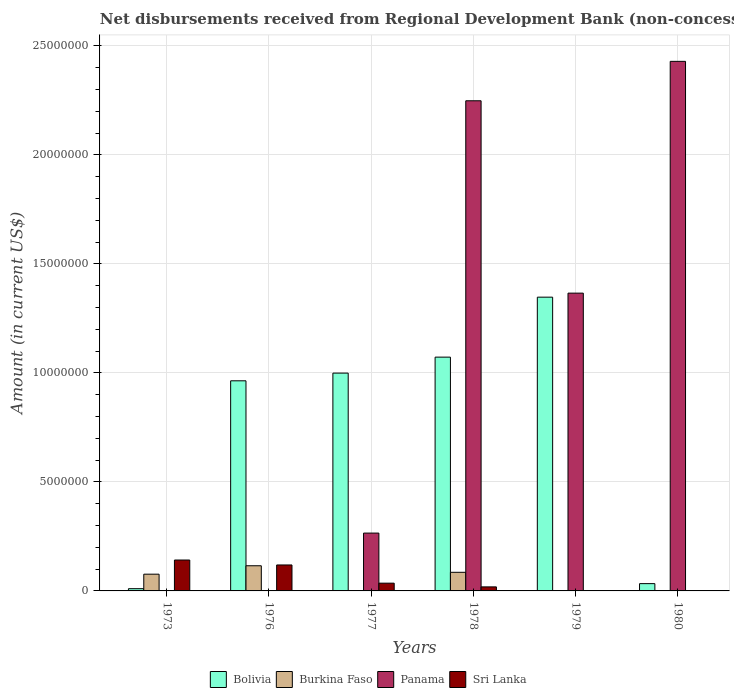Are the number of bars per tick equal to the number of legend labels?
Make the answer very short. No. Are the number of bars on each tick of the X-axis equal?
Your response must be concise. No. How many bars are there on the 5th tick from the left?
Your answer should be very brief. 2. What is the label of the 6th group of bars from the left?
Make the answer very short. 1980. In how many cases, is the number of bars for a given year not equal to the number of legend labels?
Your response must be concise. 5. What is the amount of disbursements received from Regional Development Bank in Panama in 1976?
Your answer should be very brief. 0. Across all years, what is the maximum amount of disbursements received from Regional Development Bank in Panama?
Make the answer very short. 2.43e+07. Across all years, what is the minimum amount of disbursements received from Regional Development Bank in Bolivia?
Your answer should be compact. 1.03e+05. In which year was the amount of disbursements received from Regional Development Bank in Sri Lanka maximum?
Offer a terse response. 1973. What is the total amount of disbursements received from Regional Development Bank in Sri Lanka in the graph?
Provide a short and direct response. 3.15e+06. What is the difference between the amount of disbursements received from Regional Development Bank in Bolivia in 1973 and that in 1978?
Provide a short and direct response. -1.06e+07. What is the average amount of disbursements received from Regional Development Bank in Panama per year?
Keep it short and to the point. 1.05e+07. In the year 1978, what is the difference between the amount of disbursements received from Regional Development Bank in Burkina Faso and amount of disbursements received from Regional Development Bank in Sri Lanka?
Offer a terse response. 6.69e+05. In how many years, is the amount of disbursements received from Regional Development Bank in Panama greater than 5000000 US$?
Make the answer very short. 3. What is the ratio of the amount of disbursements received from Regional Development Bank in Panama in 1978 to that in 1980?
Keep it short and to the point. 0.93. Is the amount of disbursements received from Regional Development Bank in Bolivia in 1978 less than that in 1979?
Provide a short and direct response. Yes. Is the difference between the amount of disbursements received from Regional Development Bank in Burkina Faso in 1976 and 1978 greater than the difference between the amount of disbursements received from Regional Development Bank in Sri Lanka in 1976 and 1978?
Ensure brevity in your answer.  No. What is the difference between the highest and the second highest amount of disbursements received from Regional Development Bank in Bolivia?
Give a very brief answer. 2.75e+06. What is the difference between the highest and the lowest amount of disbursements received from Regional Development Bank in Bolivia?
Offer a very short reply. 1.34e+07. In how many years, is the amount of disbursements received from Regional Development Bank in Panama greater than the average amount of disbursements received from Regional Development Bank in Panama taken over all years?
Your response must be concise. 3. Is the sum of the amount of disbursements received from Regional Development Bank in Burkina Faso in 1976 and 1978 greater than the maximum amount of disbursements received from Regional Development Bank in Bolivia across all years?
Provide a succinct answer. No. Is it the case that in every year, the sum of the amount of disbursements received from Regional Development Bank in Bolivia and amount of disbursements received from Regional Development Bank in Sri Lanka is greater than the sum of amount of disbursements received from Regional Development Bank in Panama and amount of disbursements received from Regional Development Bank in Burkina Faso?
Ensure brevity in your answer.  No. Is it the case that in every year, the sum of the amount of disbursements received from Regional Development Bank in Panama and amount of disbursements received from Regional Development Bank in Bolivia is greater than the amount of disbursements received from Regional Development Bank in Burkina Faso?
Offer a very short reply. No. How many bars are there?
Your answer should be compact. 17. Are all the bars in the graph horizontal?
Provide a short and direct response. No. Does the graph contain any zero values?
Give a very brief answer. Yes. Does the graph contain grids?
Keep it short and to the point. Yes. How many legend labels are there?
Make the answer very short. 4. How are the legend labels stacked?
Give a very brief answer. Horizontal. What is the title of the graph?
Provide a succinct answer. Net disbursements received from Regional Development Bank (non-concessional). Does "Low & middle income" appear as one of the legend labels in the graph?
Offer a very short reply. No. What is the label or title of the Y-axis?
Offer a very short reply. Amount (in current US$). What is the Amount (in current US$) of Bolivia in 1973?
Offer a terse response. 1.03e+05. What is the Amount (in current US$) in Burkina Faso in 1973?
Your answer should be very brief. 7.68e+05. What is the Amount (in current US$) in Sri Lanka in 1973?
Your answer should be very brief. 1.42e+06. What is the Amount (in current US$) of Bolivia in 1976?
Your answer should be compact. 9.64e+06. What is the Amount (in current US$) of Burkina Faso in 1976?
Offer a very short reply. 1.15e+06. What is the Amount (in current US$) in Panama in 1976?
Make the answer very short. 0. What is the Amount (in current US$) of Sri Lanka in 1976?
Provide a succinct answer. 1.19e+06. What is the Amount (in current US$) in Bolivia in 1977?
Your answer should be very brief. 9.99e+06. What is the Amount (in current US$) of Panama in 1977?
Give a very brief answer. 2.65e+06. What is the Amount (in current US$) in Sri Lanka in 1977?
Keep it short and to the point. 3.56e+05. What is the Amount (in current US$) in Bolivia in 1978?
Offer a terse response. 1.07e+07. What is the Amount (in current US$) of Burkina Faso in 1978?
Your answer should be very brief. 8.54e+05. What is the Amount (in current US$) of Panama in 1978?
Make the answer very short. 2.25e+07. What is the Amount (in current US$) of Sri Lanka in 1978?
Give a very brief answer. 1.85e+05. What is the Amount (in current US$) in Bolivia in 1979?
Give a very brief answer. 1.35e+07. What is the Amount (in current US$) of Panama in 1979?
Keep it short and to the point. 1.37e+07. What is the Amount (in current US$) in Sri Lanka in 1979?
Give a very brief answer. 0. What is the Amount (in current US$) of Bolivia in 1980?
Your response must be concise. 3.34e+05. What is the Amount (in current US$) of Panama in 1980?
Your response must be concise. 2.43e+07. Across all years, what is the maximum Amount (in current US$) in Bolivia?
Your answer should be very brief. 1.35e+07. Across all years, what is the maximum Amount (in current US$) of Burkina Faso?
Provide a succinct answer. 1.15e+06. Across all years, what is the maximum Amount (in current US$) of Panama?
Offer a terse response. 2.43e+07. Across all years, what is the maximum Amount (in current US$) in Sri Lanka?
Your answer should be very brief. 1.42e+06. Across all years, what is the minimum Amount (in current US$) of Bolivia?
Your answer should be very brief. 1.03e+05. Across all years, what is the minimum Amount (in current US$) of Panama?
Provide a short and direct response. 0. Across all years, what is the minimum Amount (in current US$) of Sri Lanka?
Provide a short and direct response. 0. What is the total Amount (in current US$) of Bolivia in the graph?
Keep it short and to the point. 4.43e+07. What is the total Amount (in current US$) of Burkina Faso in the graph?
Your answer should be very brief. 2.78e+06. What is the total Amount (in current US$) of Panama in the graph?
Make the answer very short. 6.31e+07. What is the total Amount (in current US$) of Sri Lanka in the graph?
Provide a succinct answer. 3.15e+06. What is the difference between the Amount (in current US$) in Bolivia in 1973 and that in 1976?
Provide a succinct answer. -9.54e+06. What is the difference between the Amount (in current US$) in Burkina Faso in 1973 and that in 1976?
Ensure brevity in your answer.  -3.86e+05. What is the difference between the Amount (in current US$) of Sri Lanka in 1973 and that in 1976?
Keep it short and to the point. 2.26e+05. What is the difference between the Amount (in current US$) of Bolivia in 1973 and that in 1977?
Keep it short and to the point. -9.89e+06. What is the difference between the Amount (in current US$) in Sri Lanka in 1973 and that in 1977?
Offer a terse response. 1.06e+06. What is the difference between the Amount (in current US$) of Bolivia in 1973 and that in 1978?
Make the answer very short. -1.06e+07. What is the difference between the Amount (in current US$) of Burkina Faso in 1973 and that in 1978?
Make the answer very short. -8.60e+04. What is the difference between the Amount (in current US$) of Sri Lanka in 1973 and that in 1978?
Provide a short and direct response. 1.23e+06. What is the difference between the Amount (in current US$) of Bolivia in 1973 and that in 1979?
Your answer should be very brief. -1.34e+07. What is the difference between the Amount (in current US$) in Bolivia in 1973 and that in 1980?
Your answer should be compact. -2.31e+05. What is the difference between the Amount (in current US$) of Bolivia in 1976 and that in 1977?
Make the answer very short. -3.54e+05. What is the difference between the Amount (in current US$) in Sri Lanka in 1976 and that in 1977?
Make the answer very short. 8.35e+05. What is the difference between the Amount (in current US$) in Bolivia in 1976 and that in 1978?
Offer a very short reply. -1.09e+06. What is the difference between the Amount (in current US$) of Burkina Faso in 1976 and that in 1978?
Provide a short and direct response. 3.00e+05. What is the difference between the Amount (in current US$) in Sri Lanka in 1976 and that in 1978?
Your answer should be compact. 1.01e+06. What is the difference between the Amount (in current US$) of Bolivia in 1976 and that in 1979?
Offer a terse response. -3.84e+06. What is the difference between the Amount (in current US$) in Bolivia in 1976 and that in 1980?
Keep it short and to the point. 9.30e+06. What is the difference between the Amount (in current US$) in Bolivia in 1977 and that in 1978?
Your answer should be very brief. -7.32e+05. What is the difference between the Amount (in current US$) in Panama in 1977 and that in 1978?
Your answer should be compact. -1.98e+07. What is the difference between the Amount (in current US$) in Sri Lanka in 1977 and that in 1978?
Provide a short and direct response. 1.71e+05. What is the difference between the Amount (in current US$) of Bolivia in 1977 and that in 1979?
Your answer should be very brief. -3.48e+06. What is the difference between the Amount (in current US$) in Panama in 1977 and that in 1979?
Offer a very short reply. -1.10e+07. What is the difference between the Amount (in current US$) of Bolivia in 1977 and that in 1980?
Your answer should be very brief. 9.66e+06. What is the difference between the Amount (in current US$) of Panama in 1977 and that in 1980?
Keep it short and to the point. -2.16e+07. What is the difference between the Amount (in current US$) of Bolivia in 1978 and that in 1979?
Keep it short and to the point. -2.75e+06. What is the difference between the Amount (in current US$) in Panama in 1978 and that in 1979?
Make the answer very short. 8.82e+06. What is the difference between the Amount (in current US$) of Bolivia in 1978 and that in 1980?
Provide a short and direct response. 1.04e+07. What is the difference between the Amount (in current US$) in Panama in 1978 and that in 1980?
Make the answer very short. -1.81e+06. What is the difference between the Amount (in current US$) in Bolivia in 1979 and that in 1980?
Give a very brief answer. 1.31e+07. What is the difference between the Amount (in current US$) of Panama in 1979 and that in 1980?
Provide a short and direct response. -1.06e+07. What is the difference between the Amount (in current US$) in Bolivia in 1973 and the Amount (in current US$) in Burkina Faso in 1976?
Keep it short and to the point. -1.05e+06. What is the difference between the Amount (in current US$) in Bolivia in 1973 and the Amount (in current US$) in Sri Lanka in 1976?
Offer a very short reply. -1.09e+06. What is the difference between the Amount (in current US$) in Burkina Faso in 1973 and the Amount (in current US$) in Sri Lanka in 1976?
Your response must be concise. -4.23e+05. What is the difference between the Amount (in current US$) in Bolivia in 1973 and the Amount (in current US$) in Panama in 1977?
Keep it short and to the point. -2.55e+06. What is the difference between the Amount (in current US$) in Bolivia in 1973 and the Amount (in current US$) in Sri Lanka in 1977?
Your answer should be very brief. -2.53e+05. What is the difference between the Amount (in current US$) of Burkina Faso in 1973 and the Amount (in current US$) of Panama in 1977?
Your response must be concise. -1.88e+06. What is the difference between the Amount (in current US$) of Burkina Faso in 1973 and the Amount (in current US$) of Sri Lanka in 1977?
Keep it short and to the point. 4.12e+05. What is the difference between the Amount (in current US$) of Bolivia in 1973 and the Amount (in current US$) of Burkina Faso in 1978?
Your answer should be compact. -7.51e+05. What is the difference between the Amount (in current US$) of Bolivia in 1973 and the Amount (in current US$) of Panama in 1978?
Offer a terse response. -2.24e+07. What is the difference between the Amount (in current US$) in Bolivia in 1973 and the Amount (in current US$) in Sri Lanka in 1978?
Provide a succinct answer. -8.20e+04. What is the difference between the Amount (in current US$) in Burkina Faso in 1973 and the Amount (in current US$) in Panama in 1978?
Give a very brief answer. -2.17e+07. What is the difference between the Amount (in current US$) of Burkina Faso in 1973 and the Amount (in current US$) of Sri Lanka in 1978?
Offer a very short reply. 5.83e+05. What is the difference between the Amount (in current US$) of Bolivia in 1973 and the Amount (in current US$) of Panama in 1979?
Make the answer very short. -1.36e+07. What is the difference between the Amount (in current US$) in Burkina Faso in 1973 and the Amount (in current US$) in Panama in 1979?
Give a very brief answer. -1.29e+07. What is the difference between the Amount (in current US$) in Bolivia in 1973 and the Amount (in current US$) in Panama in 1980?
Your response must be concise. -2.42e+07. What is the difference between the Amount (in current US$) of Burkina Faso in 1973 and the Amount (in current US$) of Panama in 1980?
Keep it short and to the point. -2.35e+07. What is the difference between the Amount (in current US$) of Bolivia in 1976 and the Amount (in current US$) of Panama in 1977?
Provide a succinct answer. 6.98e+06. What is the difference between the Amount (in current US$) of Bolivia in 1976 and the Amount (in current US$) of Sri Lanka in 1977?
Your answer should be very brief. 9.28e+06. What is the difference between the Amount (in current US$) in Burkina Faso in 1976 and the Amount (in current US$) in Panama in 1977?
Your response must be concise. -1.50e+06. What is the difference between the Amount (in current US$) of Burkina Faso in 1976 and the Amount (in current US$) of Sri Lanka in 1977?
Ensure brevity in your answer.  7.98e+05. What is the difference between the Amount (in current US$) of Bolivia in 1976 and the Amount (in current US$) of Burkina Faso in 1978?
Offer a very short reply. 8.78e+06. What is the difference between the Amount (in current US$) in Bolivia in 1976 and the Amount (in current US$) in Panama in 1978?
Offer a very short reply. -1.28e+07. What is the difference between the Amount (in current US$) in Bolivia in 1976 and the Amount (in current US$) in Sri Lanka in 1978?
Offer a terse response. 9.45e+06. What is the difference between the Amount (in current US$) of Burkina Faso in 1976 and the Amount (in current US$) of Panama in 1978?
Your answer should be very brief. -2.13e+07. What is the difference between the Amount (in current US$) of Burkina Faso in 1976 and the Amount (in current US$) of Sri Lanka in 1978?
Provide a succinct answer. 9.69e+05. What is the difference between the Amount (in current US$) in Bolivia in 1976 and the Amount (in current US$) in Panama in 1979?
Provide a short and direct response. -4.02e+06. What is the difference between the Amount (in current US$) of Burkina Faso in 1976 and the Amount (in current US$) of Panama in 1979?
Ensure brevity in your answer.  -1.25e+07. What is the difference between the Amount (in current US$) in Bolivia in 1976 and the Amount (in current US$) in Panama in 1980?
Keep it short and to the point. -1.47e+07. What is the difference between the Amount (in current US$) of Burkina Faso in 1976 and the Amount (in current US$) of Panama in 1980?
Your response must be concise. -2.31e+07. What is the difference between the Amount (in current US$) of Bolivia in 1977 and the Amount (in current US$) of Burkina Faso in 1978?
Give a very brief answer. 9.14e+06. What is the difference between the Amount (in current US$) in Bolivia in 1977 and the Amount (in current US$) in Panama in 1978?
Offer a terse response. -1.25e+07. What is the difference between the Amount (in current US$) of Bolivia in 1977 and the Amount (in current US$) of Sri Lanka in 1978?
Your answer should be very brief. 9.81e+06. What is the difference between the Amount (in current US$) of Panama in 1977 and the Amount (in current US$) of Sri Lanka in 1978?
Your answer should be very brief. 2.47e+06. What is the difference between the Amount (in current US$) of Bolivia in 1977 and the Amount (in current US$) of Panama in 1979?
Keep it short and to the point. -3.67e+06. What is the difference between the Amount (in current US$) of Bolivia in 1977 and the Amount (in current US$) of Panama in 1980?
Ensure brevity in your answer.  -1.43e+07. What is the difference between the Amount (in current US$) of Bolivia in 1978 and the Amount (in current US$) of Panama in 1979?
Ensure brevity in your answer.  -2.94e+06. What is the difference between the Amount (in current US$) in Burkina Faso in 1978 and the Amount (in current US$) in Panama in 1979?
Your answer should be very brief. -1.28e+07. What is the difference between the Amount (in current US$) of Bolivia in 1978 and the Amount (in current US$) of Panama in 1980?
Ensure brevity in your answer.  -1.36e+07. What is the difference between the Amount (in current US$) of Burkina Faso in 1978 and the Amount (in current US$) of Panama in 1980?
Make the answer very short. -2.34e+07. What is the difference between the Amount (in current US$) in Bolivia in 1979 and the Amount (in current US$) in Panama in 1980?
Ensure brevity in your answer.  -1.08e+07. What is the average Amount (in current US$) of Bolivia per year?
Keep it short and to the point. 7.38e+06. What is the average Amount (in current US$) in Burkina Faso per year?
Ensure brevity in your answer.  4.63e+05. What is the average Amount (in current US$) of Panama per year?
Ensure brevity in your answer.  1.05e+07. What is the average Amount (in current US$) of Sri Lanka per year?
Give a very brief answer. 5.25e+05. In the year 1973, what is the difference between the Amount (in current US$) of Bolivia and Amount (in current US$) of Burkina Faso?
Give a very brief answer. -6.65e+05. In the year 1973, what is the difference between the Amount (in current US$) of Bolivia and Amount (in current US$) of Sri Lanka?
Offer a very short reply. -1.31e+06. In the year 1973, what is the difference between the Amount (in current US$) of Burkina Faso and Amount (in current US$) of Sri Lanka?
Keep it short and to the point. -6.49e+05. In the year 1976, what is the difference between the Amount (in current US$) of Bolivia and Amount (in current US$) of Burkina Faso?
Give a very brief answer. 8.48e+06. In the year 1976, what is the difference between the Amount (in current US$) of Bolivia and Amount (in current US$) of Sri Lanka?
Keep it short and to the point. 8.45e+06. In the year 1976, what is the difference between the Amount (in current US$) of Burkina Faso and Amount (in current US$) of Sri Lanka?
Provide a short and direct response. -3.70e+04. In the year 1977, what is the difference between the Amount (in current US$) in Bolivia and Amount (in current US$) in Panama?
Your response must be concise. 7.34e+06. In the year 1977, what is the difference between the Amount (in current US$) of Bolivia and Amount (in current US$) of Sri Lanka?
Keep it short and to the point. 9.64e+06. In the year 1977, what is the difference between the Amount (in current US$) of Panama and Amount (in current US$) of Sri Lanka?
Your answer should be compact. 2.30e+06. In the year 1978, what is the difference between the Amount (in current US$) of Bolivia and Amount (in current US$) of Burkina Faso?
Provide a succinct answer. 9.87e+06. In the year 1978, what is the difference between the Amount (in current US$) in Bolivia and Amount (in current US$) in Panama?
Provide a short and direct response. -1.18e+07. In the year 1978, what is the difference between the Amount (in current US$) in Bolivia and Amount (in current US$) in Sri Lanka?
Ensure brevity in your answer.  1.05e+07. In the year 1978, what is the difference between the Amount (in current US$) of Burkina Faso and Amount (in current US$) of Panama?
Give a very brief answer. -2.16e+07. In the year 1978, what is the difference between the Amount (in current US$) in Burkina Faso and Amount (in current US$) in Sri Lanka?
Provide a succinct answer. 6.69e+05. In the year 1978, what is the difference between the Amount (in current US$) of Panama and Amount (in current US$) of Sri Lanka?
Your answer should be very brief. 2.23e+07. In the year 1979, what is the difference between the Amount (in current US$) in Bolivia and Amount (in current US$) in Panama?
Make the answer very short. -1.85e+05. In the year 1980, what is the difference between the Amount (in current US$) of Bolivia and Amount (in current US$) of Panama?
Your response must be concise. -2.40e+07. What is the ratio of the Amount (in current US$) of Bolivia in 1973 to that in 1976?
Keep it short and to the point. 0.01. What is the ratio of the Amount (in current US$) in Burkina Faso in 1973 to that in 1976?
Give a very brief answer. 0.67. What is the ratio of the Amount (in current US$) of Sri Lanka in 1973 to that in 1976?
Your answer should be compact. 1.19. What is the ratio of the Amount (in current US$) in Bolivia in 1973 to that in 1977?
Make the answer very short. 0.01. What is the ratio of the Amount (in current US$) of Sri Lanka in 1973 to that in 1977?
Provide a succinct answer. 3.98. What is the ratio of the Amount (in current US$) in Bolivia in 1973 to that in 1978?
Give a very brief answer. 0.01. What is the ratio of the Amount (in current US$) of Burkina Faso in 1973 to that in 1978?
Your response must be concise. 0.9. What is the ratio of the Amount (in current US$) in Sri Lanka in 1973 to that in 1978?
Your answer should be very brief. 7.66. What is the ratio of the Amount (in current US$) of Bolivia in 1973 to that in 1979?
Make the answer very short. 0.01. What is the ratio of the Amount (in current US$) in Bolivia in 1973 to that in 1980?
Ensure brevity in your answer.  0.31. What is the ratio of the Amount (in current US$) in Bolivia in 1976 to that in 1977?
Your response must be concise. 0.96. What is the ratio of the Amount (in current US$) in Sri Lanka in 1976 to that in 1977?
Offer a terse response. 3.35. What is the ratio of the Amount (in current US$) of Bolivia in 1976 to that in 1978?
Offer a very short reply. 0.9. What is the ratio of the Amount (in current US$) of Burkina Faso in 1976 to that in 1978?
Give a very brief answer. 1.35. What is the ratio of the Amount (in current US$) of Sri Lanka in 1976 to that in 1978?
Make the answer very short. 6.44. What is the ratio of the Amount (in current US$) of Bolivia in 1976 to that in 1979?
Make the answer very short. 0.72. What is the ratio of the Amount (in current US$) of Bolivia in 1976 to that in 1980?
Offer a very short reply. 28.86. What is the ratio of the Amount (in current US$) of Bolivia in 1977 to that in 1978?
Your response must be concise. 0.93. What is the ratio of the Amount (in current US$) of Panama in 1977 to that in 1978?
Provide a succinct answer. 0.12. What is the ratio of the Amount (in current US$) of Sri Lanka in 1977 to that in 1978?
Ensure brevity in your answer.  1.92. What is the ratio of the Amount (in current US$) in Bolivia in 1977 to that in 1979?
Your answer should be compact. 0.74. What is the ratio of the Amount (in current US$) in Panama in 1977 to that in 1979?
Your answer should be very brief. 0.19. What is the ratio of the Amount (in current US$) in Bolivia in 1977 to that in 1980?
Keep it short and to the point. 29.92. What is the ratio of the Amount (in current US$) in Panama in 1977 to that in 1980?
Provide a succinct answer. 0.11. What is the ratio of the Amount (in current US$) in Bolivia in 1978 to that in 1979?
Offer a very short reply. 0.8. What is the ratio of the Amount (in current US$) in Panama in 1978 to that in 1979?
Ensure brevity in your answer.  1.65. What is the ratio of the Amount (in current US$) of Bolivia in 1978 to that in 1980?
Give a very brief answer. 32.11. What is the ratio of the Amount (in current US$) of Panama in 1978 to that in 1980?
Your response must be concise. 0.93. What is the ratio of the Amount (in current US$) of Bolivia in 1979 to that in 1980?
Ensure brevity in your answer.  40.34. What is the ratio of the Amount (in current US$) in Panama in 1979 to that in 1980?
Make the answer very short. 0.56. What is the difference between the highest and the second highest Amount (in current US$) in Bolivia?
Make the answer very short. 2.75e+06. What is the difference between the highest and the second highest Amount (in current US$) in Burkina Faso?
Make the answer very short. 3.00e+05. What is the difference between the highest and the second highest Amount (in current US$) of Panama?
Offer a terse response. 1.81e+06. What is the difference between the highest and the second highest Amount (in current US$) of Sri Lanka?
Make the answer very short. 2.26e+05. What is the difference between the highest and the lowest Amount (in current US$) of Bolivia?
Give a very brief answer. 1.34e+07. What is the difference between the highest and the lowest Amount (in current US$) of Burkina Faso?
Offer a very short reply. 1.15e+06. What is the difference between the highest and the lowest Amount (in current US$) of Panama?
Provide a succinct answer. 2.43e+07. What is the difference between the highest and the lowest Amount (in current US$) of Sri Lanka?
Make the answer very short. 1.42e+06. 